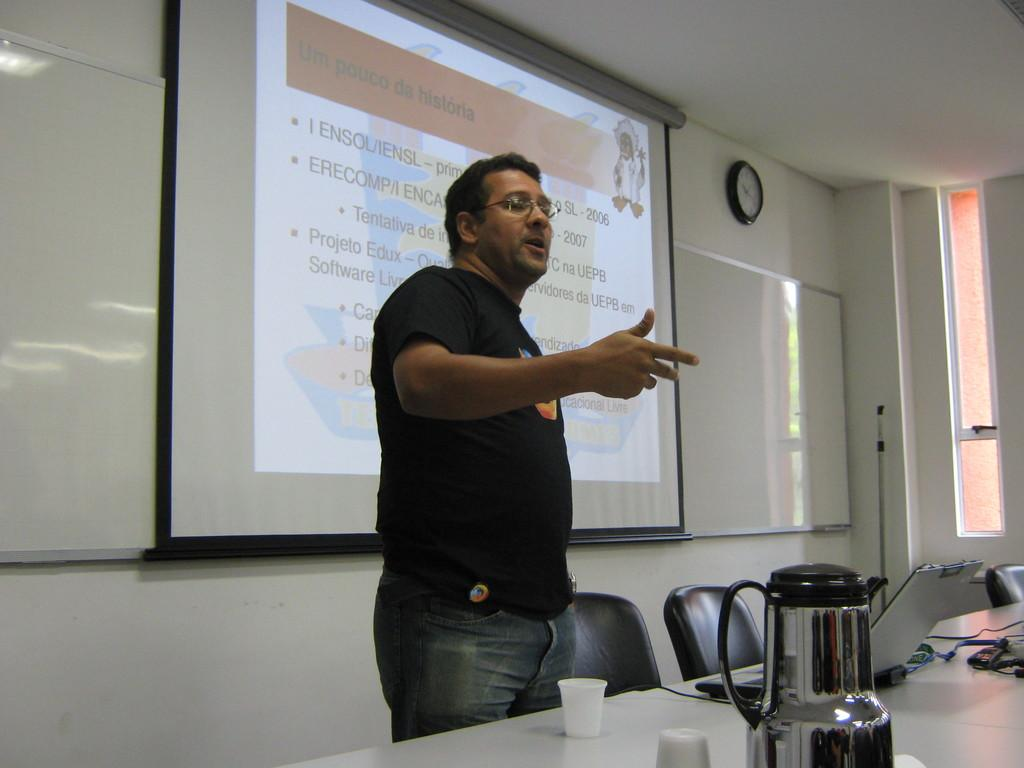<image>
Create a compact narrative representing the image presented. Man standing in front of a screen which says "Ensol/Iensl" on it. 